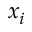<formula> <loc_0><loc_0><loc_500><loc_500>x _ { i }</formula> 